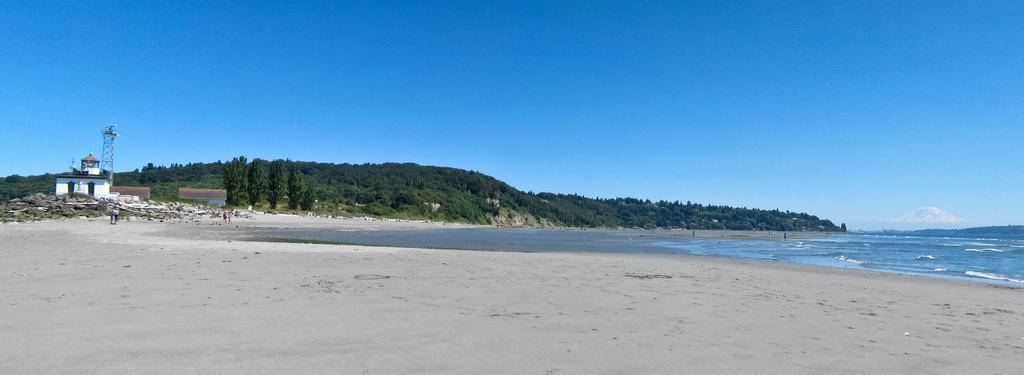How would you summarize this image in a sentence or two? In this image there are few people in the sea shore, there are few mountains covered with trees, an ocean, few houses, a tower, few stones and the sky. 